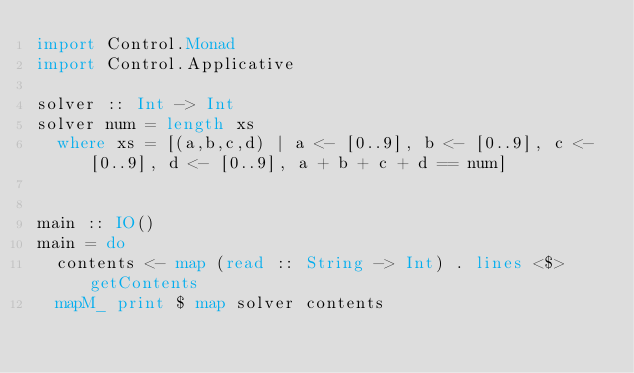<code> <loc_0><loc_0><loc_500><loc_500><_Haskell_>import Control.Monad
import Control.Applicative

solver :: Int -> Int
solver num = length xs
  where xs = [(a,b,c,d) | a <- [0..9], b <- [0..9], c <- [0..9], d <- [0..9], a + b + c + d == num]


main :: IO()
main = do
  contents <- map (read :: String -> Int) . lines <$> getContents
  mapM_ print $ map solver contents</code> 